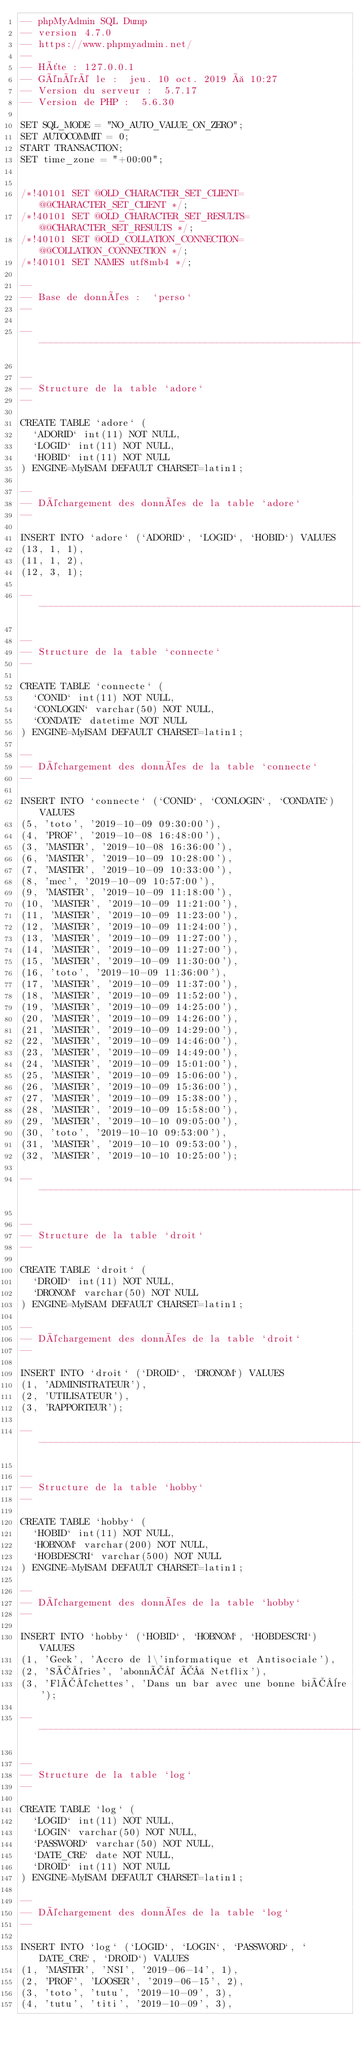Convert code to text. <code><loc_0><loc_0><loc_500><loc_500><_SQL_>-- phpMyAdmin SQL Dump
-- version 4.7.0
-- https://www.phpmyadmin.net/
--
-- Hôte : 127.0.0.1
-- Généré le :  jeu. 10 oct. 2019 à 10:27
-- Version du serveur :  5.7.17
-- Version de PHP :  5.6.30

SET SQL_MODE = "NO_AUTO_VALUE_ON_ZERO";
SET AUTOCOMMIT = 0;
START TRANSACTION;
SET time_zone = "+00:00";


/*!40101 SET @OLD_CHARACTER_SET_CLIENT=@@CHARACTER_SET_CLIENT */;
/*!40101 SET @OLD_CHARACTER_SET_RESULTS=@@CHARACTER_SET_RESULTS */;
/*!40101 SET @OLD_COLLATION_CONNECTION=@@COLLATION_CONNECTION */;
/*!40101 SET NAMES utf8mb4 */;

--
-- Base de données :  `perso`
--

-- --------------------------------------------------------

--
-- Structure de la table `adore`
--

CREATE TABLE `adore` (
  `ADORID` int(11) NOT NULL,
  `LOGID` int(11) NOT NULL,
  `HOBID` int(11) NOT NULL
) ENGINE=MyISAM DEFAULT CHARSET=latin1;

--
-- Déchargement des données de la table `adore`
--

INSERT INTO `adore` (`ADORID`, `LOGID`, `HOBID`) VALUES
(13, 1, 1),
(11, 1, 2),
(12, 3, 1);

-- --------------------------------------------------------

--
-- Structure de la table `connecte`
--

CREATE TABLE `connecte` (
  `CONID` int(11) NOT NULL,
  `CONLOGIN` varchar(50) NOT NULL,
  `CONDATE` datetime NOT NULL
) ENGINE=MyISAM DEFAULT CHARSET=latin1;

--
-- Déchargement des données de la table `connecte`
--

INSERT INTO `connecte` (`CONID`, `CONLOGIN`, `CONDATE`) VALUES
(5, 'toto', '2019-10-09 09:30:00'),
(4, 'PROF', '2019-10-08 16:48:00'),
(3, 'MASTER', '2019-10-08 16:36:00'),
(6, 'MASTER', '2019-10-09 10:28:00'),
(7, 'MASTER', '2019-10-09 10:33:00'),
(8, 'mec', '2019-10-09 10:57:00'),
(9, 'MASTER', '2019-10-09 11:18:00'),
(10, 'MASTER', '2019-10-09 11:21:00'),
(11, 'MASTER', '2019-10-09 11:23:00'),
(12, 'MASTER', '2019-10-09 11:24:00'),
(13, 'MASTER', '2019-10-09 11:27:00'),
(14, 'MASTER', '2019-10-09 11:27:00'),
(15, 'MASTER', '2019-10-09 11:30:00'),
(16, 'toto', '2019-10-09 11:36:00'),
(17, 'MASTER', '2019-10-09 11:37:00'),
(18, 'MASTER', '2019-10-09 11:52:00'),
(19, 'MASTER', '2019-10-09 14:25:00'),
(20, 'MASTER', '2019-10-09 14:26:00'),
(21, 'MASTER', '2019-10-09 14:29:00'),
(22, 'MASTER', '2019-10-09 14:46:00'),
(23, 'MASTER', '2019-10-09 14:49:00'),
(24, 'MASTER', '2019-10-09 15:01:00'),
(25, 'MASTER', '2019-10-09 15:06:00'),
(26, 'MASTER', '2019-10-09 15:36:00'),
(27, 'MASTER', '2019-10-09 15:38:00'),
(28, 'MASTER', '2019-10-09 15:58:00'),
(29, 'MASTER', '2019-10-10 09:05:00'),
(30, 'toto', '2019-10-10 09:53:00'),
(31, 'MASTER', '2019-10-10 09:53:00'),
(32, 'MASTER', '2019-10-10 10:25:00');

-- --------------------------------------------------------

--
-- Structure de la table `droit`
--

CREATE TABLE `droit` (
  `DROID` int(11) NOT NULL,
  `DRONOM` varchar(50) NOT NULL
) ENGINE=MyISAM DEFAULT CHARSET=latin1;

--
-- Déchargement des données de la table `droit`
--

INSERT INTO `droit` (`DROID`, `DRONOM`) VALUES
(1, 'ADMINISTRATEUR'),
(2, 'UTILISATEUR'),
(3, 'RAPPORTEUR');

-- --------------------------------------------------------

--
-- Structure de la table `hobby`
--

CREATE TABLE `hobby` (
  `HOBID` int(11) NOT NULL,
  `HOBNOM` varchar(200) NOT NULL,
  `HOBDESCRI` varchar(500) NOT NULL
) ENGINE=MyISAM DEFAULT CHARSET=latin1;

--
-- Déchargement des données de la table `hobby`
--

INSERT INTO `hobby` (`HOBID`, `HOBNOM`, `HOBDESCRI`) VALUES
(1, 'Geek', 'Accro de l\'informatique et Antisociale'),
(2, 'SÃ©ries', 'abonnÃ© Ã  Netflix'),
(3, 'FlÃ©chettes', 'Dans un bar avec une bonne biÃ¨re');

-- --------------------------------------------------------

--
-- Structure de la table `log`
--

CREATE TABLE `log` (
  `LOGID` int(11) NOT NULL,
  `LOGIN` varchar(50) NOT NULL,
  `PASSWORD` varchar(50) NOT NULL,
  `DATE_CRE` date NOT NULL,
  `DROID` int(11) NOT NULL
) ENGINE=MyISAM DEFAULT CHARSET=latin1;

--
-- Déchargement des données de la table `log`
--

INSERT INTO `log` (`LOGID`, `LOGIN`, `PASSWORD`, `DATE_CRE`, `DROID`) VALUES
(1, 'MASTER', 'NSI', '2019-06-14', 1),
(2, 'PROF', 'LOOSER', '2019-06-15', 2),
(3, 'toto', 'tutu', '2019-10-09', 3),
(4, 'tutu', 'titi', '2019-10-09', 3),</code> 